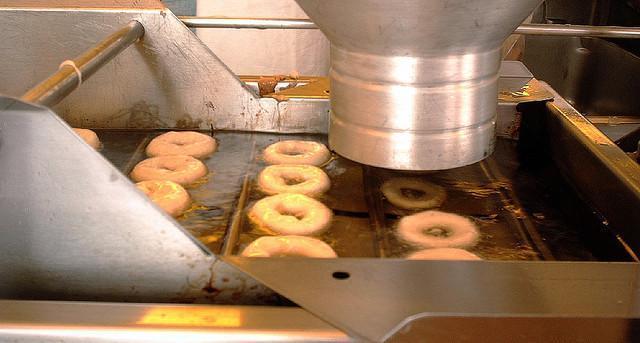How many donuts are visible?
Give a very brief answer. 2. 